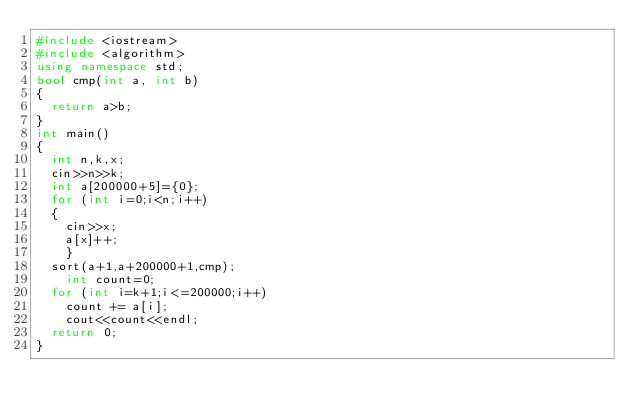Convert code to text. <code><loc_0><loc_0><loc_500><loc_500><_C++_>#include <iostream> 
#include <algorithm> 
using namespace std; 
bool cmp(int a, int b)
{  
	return a>b; 
} 
int main()
{  
	int n,k,x;  
	cin>>n>>k;  
	int a[200000+5]={0}; 
 	for (int i=0;i<n;i++)
	{     
		cin>>x;     
		a[x]++; 
    }          
	sort(a+1,a+200000+1,cmp); 
    int count=0;
	for (int i=k+1;i<=200000;i++) 
	  count += a[i]; 
    cout<<count<<endl;     
	return 0; 
} 
</code> 